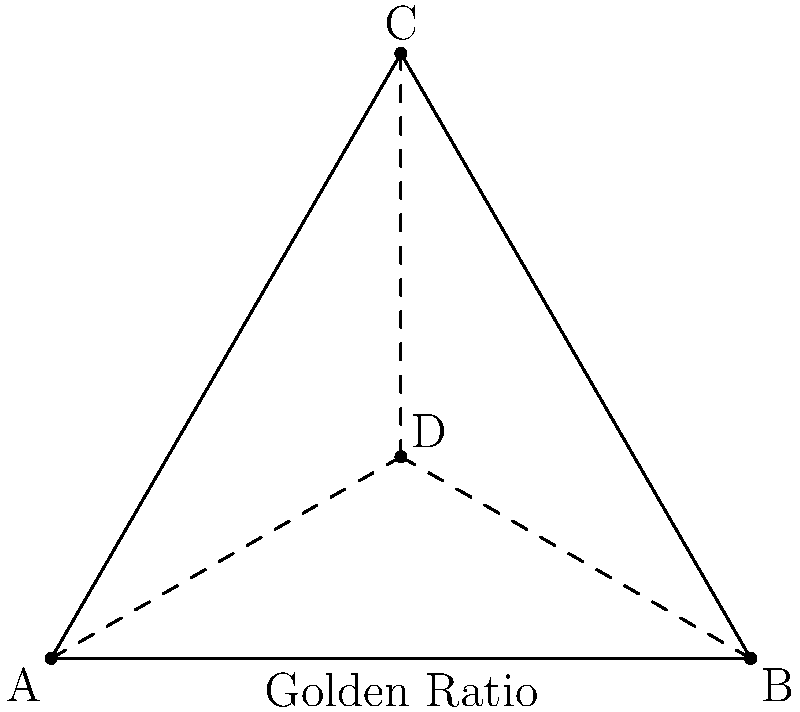In the context of sacred geometry found in ancient cultural sites, the triangle above represents a fundamental shape often associated with language and communication. If the triangle ABC is equilateral and its centroid is point D, what is the ratio of AD to DC, and how might this relate to language preservation efforts? To solve this problem and understand its relevance to language preservation, let's follow these steps:

1) In an equilateral triangle, the centroid divides each median in the ratio 2:1, with the longer segment closer to the vertex.

2) This means that $AD : DC = 2 : 1$

3) This 2:1 ratio is significant in sacred geometry and is often associated with balance and harmony.

4) In the context of language preservation:
   a) The triangle represents the three key elements of language: speaking, writing, and comprehension.
   b) The centroid (point D) represents the balance point or the "core" of the language.
   c) The 2:1 ratio suggests that for effective language preservation, twice as much effort should be put into active language use (represented by the longer segment AD) compared to passive preservation (represented by DC).

5) This geometric principle can guide language revitalization initiatives by emphasizing:
   a) Active language use in communities (speaking, writing)
   b) Creating opportunities for language immersion
   c) Developing modern contexts for language use (e.g., social media, apps)
   d) While also maintaining traditional preservation methods (documentation, recordings)

6) The Golden Ratio, another sacred geometric principle often found in ancient sites, can be applied to language preservation by balancing innovation with tradition in revitalization efforts.
Answer: $AD : DC = 2 : 1$, emphasizing active language use over passive preservation in revitalization efforts. 